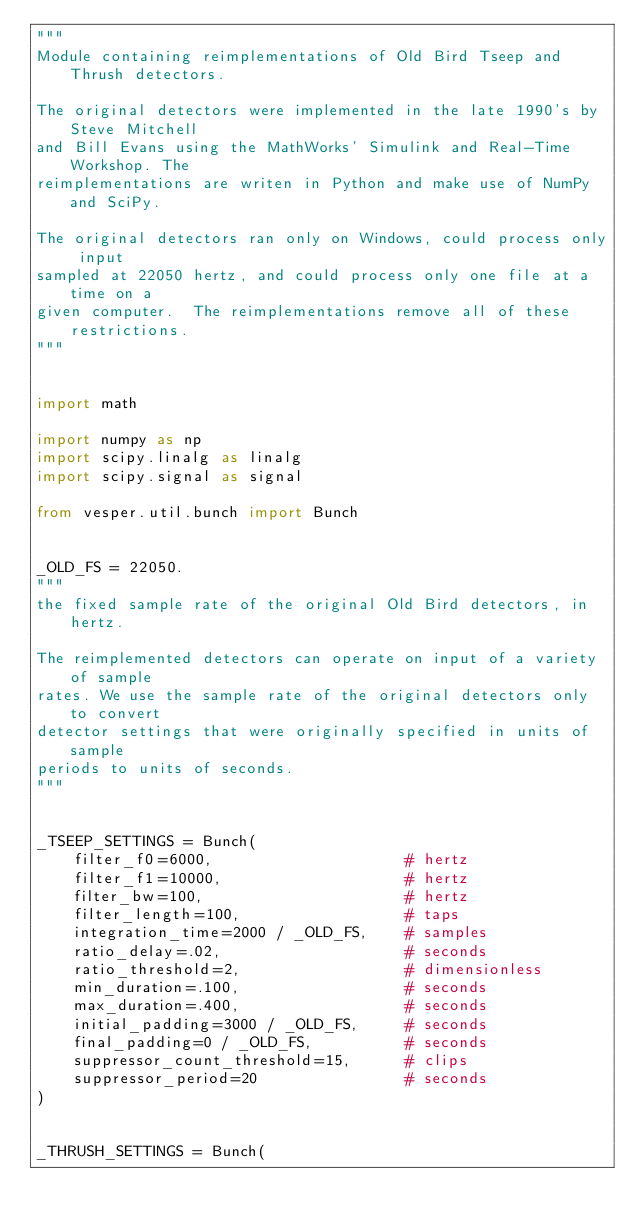<code> <loc_0><loc_0><loc_500><loc_500><_Python_>"""
Module containing reimplementations of Old Bird Tseep and Thrush detectors.

The original detectors were implemented in the late 1990's by Steve Mitchell
and Bill Evans using the MathWorks' Simulink and Real-Time Workshop. The
reimplementations are writen in Python and make use of NumPy and SciPy.

The original detectors ran only on Windows, could process only input
sampled at 22050 hertz, and could process only one file at a time on a
given computer.  The reimplementations remove all of these restrictions.
"""


import math

import numpy as np
import scipy.linalg as linalg
import scipy.signal as signal

from vesper.util.bunch import Bunch


_OLD_FS = 22050.
"""
the fixed sample rate of the original Old Bird detectors, in hertz.

The reimplemented detectors can operate on input of a variety of sample
rates. We use the sample rate of the original detectors only to convert
detector settings that were originally specified in units of sample
periods to units of seconds.
"""


_TSEEP_SETTINGS = Bunch(
    filter_f0=6000,                     # hertz
    filter_f1=10000,                    # hertz
    filter_bw=100,                      # hertz
    filter_length=100,                  # taps
    integration_time=2000 / _OLD_FS,    # samples
    ratio_delay=.02,                    # seconds
    ratio_threshold=2,                  # dimensionless
    min_duration=.100,                  # seconds
    max_duration=.400,                  # seconds
    initial_padding=3000 / _OLD_FS,     # seconds
    final_padding=0 / _OLD_FS,          # seconds
    suppressor_count_threshold=15,      # clips
    suppressor_period=20                # seconds
)


_THRUSH_SETTINGS = Bunch(</code> 